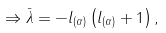Convert formula to latex. <formula><loc_0><loc_0><loc_500><loc_500>\Rightarrow \bar { \lambda } = - l _ { ( \alpha ) } \left ( l _ { ( \alpha ) } + 1 \right ) ,</formula> 